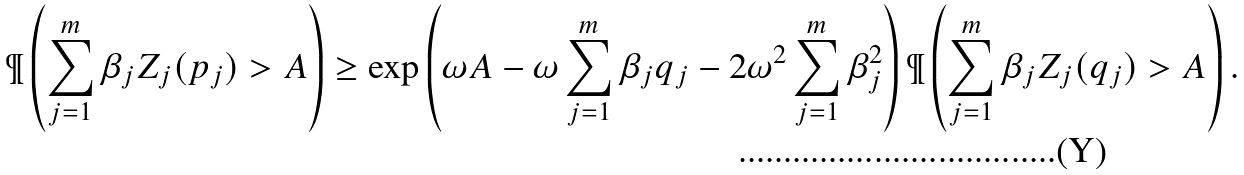Convert formula to latex. <formula><loc_0><loc_0><loc_500><loc_500>\P \left ( \sum _ { j = 1 } ^ { m } \beta _ { j } Z _ { j } ( p _ { j } ) > A \right ) \geq \exp \left ( \omega A - \omega \sum _ { j = 1 } ^ { m } \beta _ { j } q _ { j } - 2 \omega ^ { 2 } \sum _ { j = 1 } ^ { m } \beta _ { j } ^ { 2 } \right ) \P \left ( \sum _ { j = 1 } ^ { m } \beta _ { j } Z _ { j } ( q _ { j } ) > A \right ) .</formula> 